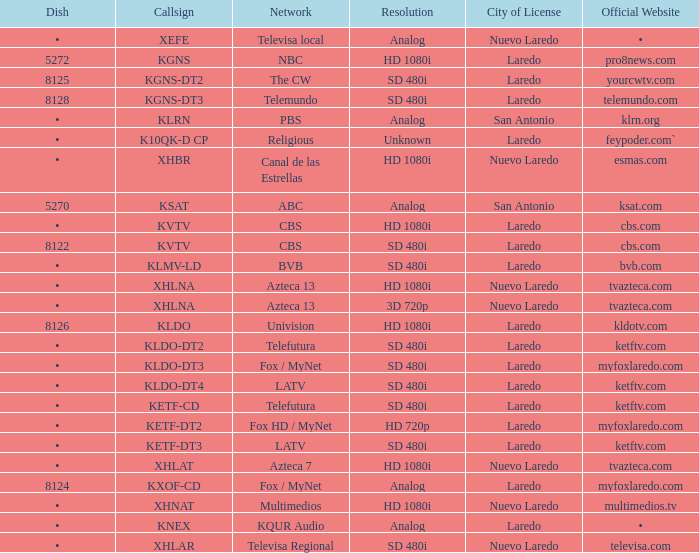What is the cuisine for a 480i sd resolution and bvb network connection? •. Parse the full table. {'header': ['Dish', 'Callsign', 'Network', 'Resolution', 'City of License', 'Official Website'], 'rows': [['•', 'XEFE', 'Televisa local', 'Analog', 'Nuevo Laredo', '•'], ['5272', 'KGNS', 'NBC', 'HD 1080i', 'Laredo', 'pro8news.com'], ['8125', 'KGNS-DT2', 'The CW', 'SD 480i', 'Laredo', 'yourcwtv.com'], ['8128', 'KGNS-DT3', 'Telemundo', 'SD 480i', 'Laredo', 'telemundo.com'], ['•', 'KLRN', 'PBS', 'Analog', 'San Antonio', 'klrn.org'], ['•', 'K10QK-D CP', 'Religious', 'Unknown', 'Laredo', 'feypoder.com`'], ['•', 'XHBR', 'Canal de las Estrellas', 'HD 1080i', 'Nuevo Laredo', 'esmas.com'], ['5270', 'KSAT', 'ABC', 'Analog', 'San Antonio', 'ksat.com'], ['•', 'KVTV', 'CBS', 'HD 1080i', 'Laredo', 'cbs.com'], ['8122', 'KVTV', 'CBS', 'SD 480i', 'Laredo', 'cbs.com'], ['•', 'KLMV-LD', 'BVB', 'SD 480i', 'Laredo', 'bvb.com'], ['•', 'XHLNA', 'Azteca 13', 'HD 1080i', 'Nuevo Laredo', 'tvazteca.com'], ['•', 'XHLNA', 'Azteca 13', '3D 720p', 'Nuevo Laredo', 'tvazteca.com'], ['8126', 'KLDO', 'Univision', 'HD 1080i', 'Laredo', 'kldotv.com'], ['•', 'KLDO-DT2', 'Telefutura', 'SD 480i', 'Laredo', 'ketftv.com'], ['•', 'KLDO-DT3', 'Fox / MyNet', 'SD 480i', 'Laredo', 'myfoxlaredo.com'], ['•', 'KLDO-DT4', 'LATV', 'SD 480i', 'Laredo', 'ketftv.com'], ['•', 'KETF-CD', 'Telefutura', 'SD 480i', 'Laredo', 'ketftv.com'], ['•', 'KETF-DT2', 'Fox HD / MyNet', 'HD 720p', 'Laredo', 'myfoxlaredo.com'], ['•', 'KETF-DT3', 'LATV', 'SD 480i', 'Laredo', 'ketftv.com'], ['•', 'XHLAT', 'Azteca 7', 'HD 1080i', 'Nuevo Laredo', 'tvazteca.com'], ['8124', 'KXOF-CD', 'Fox / MyNet', 'Analog', 'Laredo', 'myfoxlaredo.com'], ['•', 'XHNAT', 'Multimedios', 'HD 1080i', 'Nuevo Laredo', 'multimedios.tv'], ['•', 'KNEX', 'KQUR Audio', 'Analog', 'Laredo', '•'], ['•', 'XHLAR', 'Televisa Regional', 'SD 480i', 'Nuevo Laredo', 'televisa.com']]} 